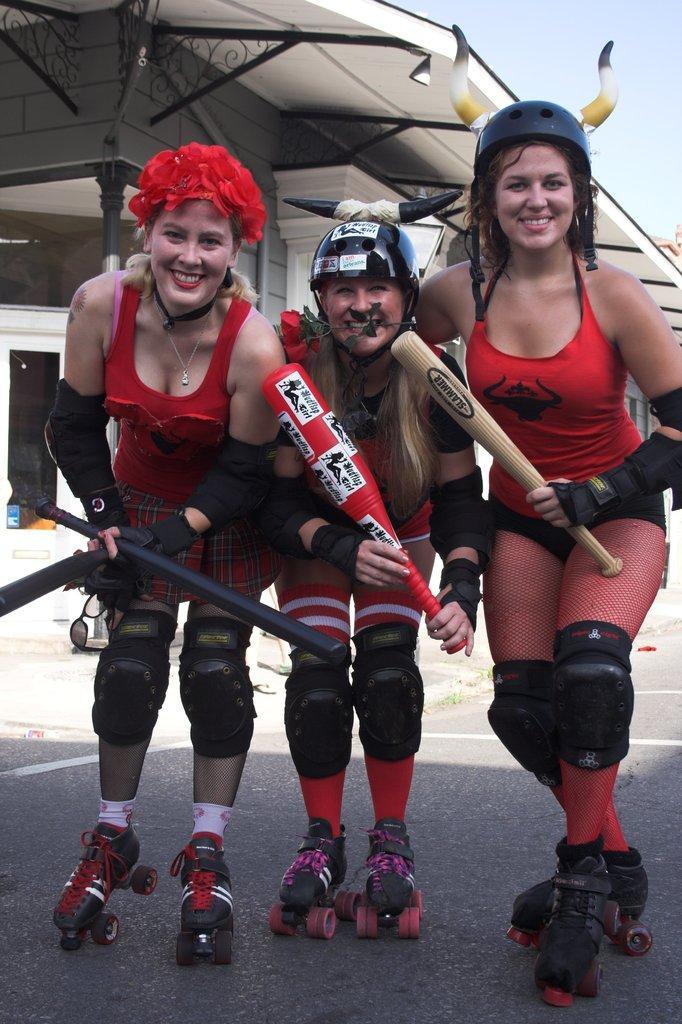How would you summarize this image in a sentence or two? In this image, we can see people skating shoes and holding bags and wearing helmets, one of them is wearing a cap and we can see a flower. At the bottom, there is a road and at the top, there is sky. 